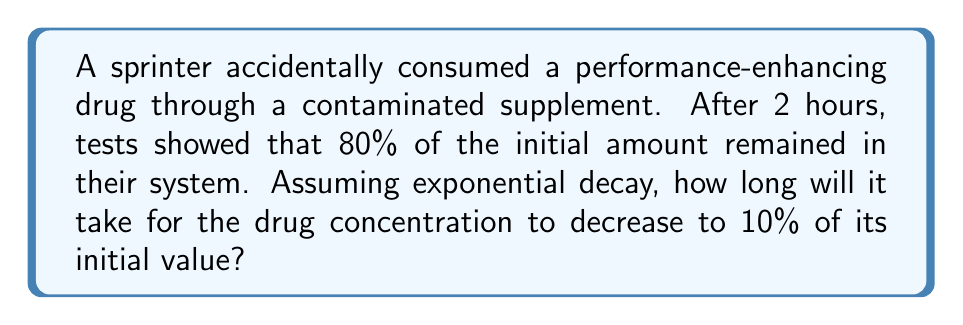Can you solve this math problem? Let's approach this step-by-step using the exponential decay model:

1) The general form of exponential decay is:

   $$ A(t) = A_0 e^{-kt} $$

   where $A(t)$ is the amount at time $t$, $A_0$ is the initial amount, $k$ is the decay constant, and $t$ is time.

2) We're given that after 2 hours, 80% of the initial amount remains. Let's use this to find $k$:

   $$ 0.8A_0 = A_0 e^{-k(2)} $$

3) Dividing both sides by $A_0$:

   $$ 0.8 = e^{-2k} $$

4) Taking the natural log of both sides:

   $$ \ln(0.8) = -2k $$

5) Solving for $k$:

   $$ k = -\frac{\ln(0.8)}{2} \approx 0.1115 $$

6) Now, we want to find $t$ when the concentration is 10% of the initial value:

   $$ 0.1A_0 = A_0 e^{-0.1115t} $$

7) Dividing both sides by $A_0$:

   $$ 0.1 = e^{-0.1115t} $$

8) Taking the natural log of both sides:

   $$ \ln(0.1) = -0.1115t $$

9) Solving for $t$:

   $$ t = -\frac{\ln(0.1)}{0.1115} \approx 20.59 $$

Therefore, it will take approximately 20.59 hours for the drug concentration to decrease to 10% of its initial value.
Answer: 20.59 hours 